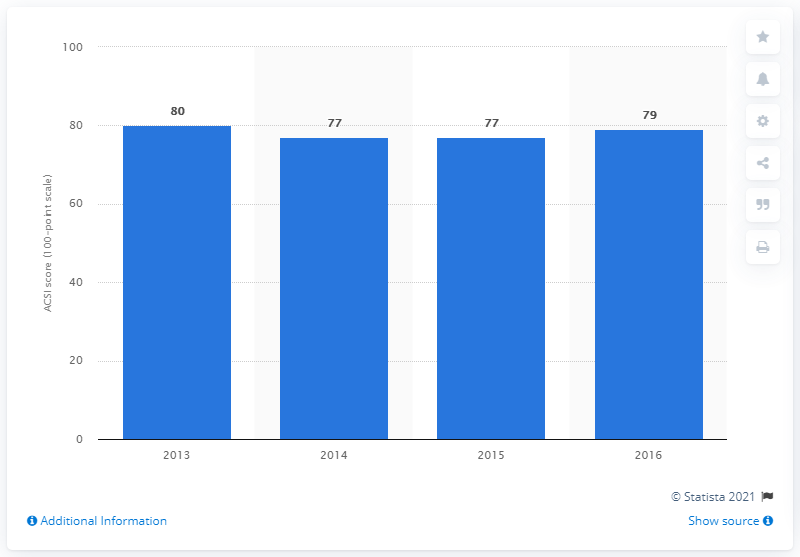Give some essential details in this illustration. In 2016, the customer satisfaction score for Etsy was 79%. 